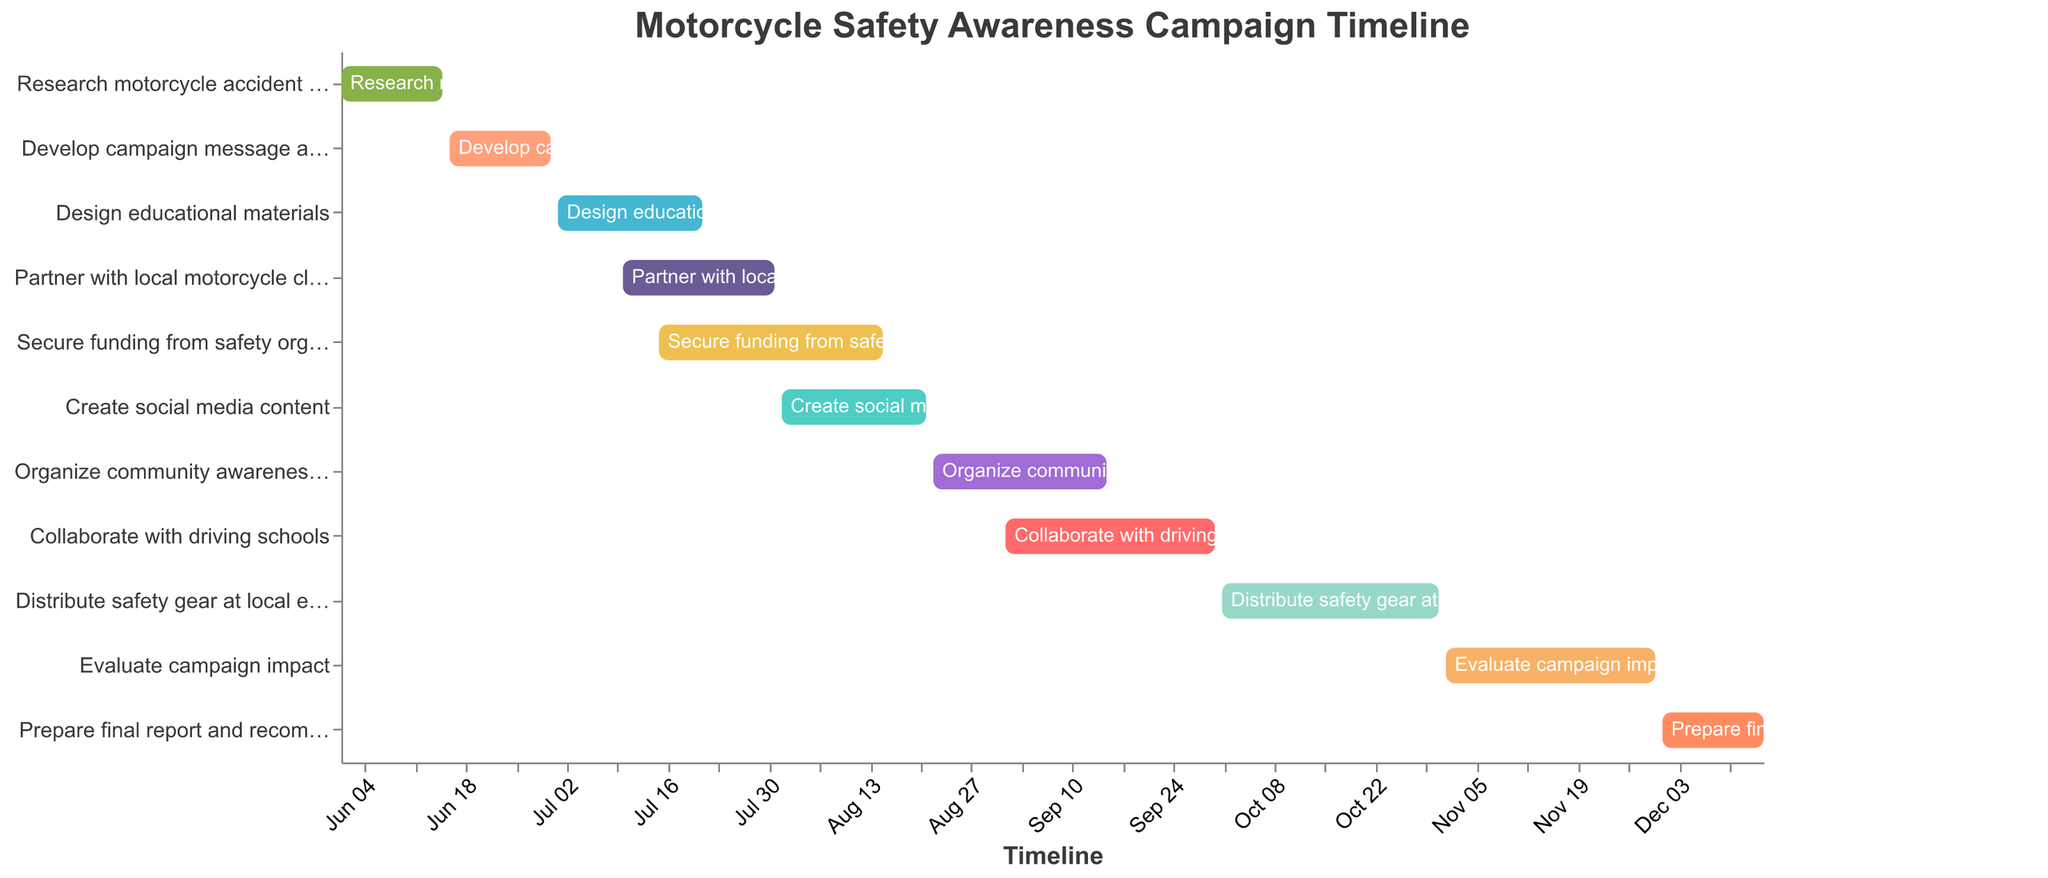How long was the “Research motorcycle accident statistics” phase? Check the dates for "Research motorcycle accident statistics," which spans from June 1, 2023, to June 15, 2023. Count the days between these two dates.
Answer: 15 days What is the title of the figure? Refer to the top section of the figure where the title is usually displayed.
Answer: Motorcycle Safety Awareness Campaign Timeline When does the "Design educational materials" task end? Locate the task "Design educational materials" and check the end date listed for this task.
Answer: July 21, 2023 Which task starts at the earliest date? Look for the task with the earliest start date in the list of tasks.
Answer: Research motorcycle accident statistics How many tasks are scheduled to end in September 2023? Identify tasks with end dates in September 2023. There are two tasks: "Organize community awareness events" (September 15, 2023) and "Collaborate with driving schools" (September 30, 2023). Count them.
Answer: 2 tasks Which task has the longest duration? Calculate the duration of each task by subtracting the start date from the end date. Identify the task with the longest duration.
Answer: Secure funding from safety organizations (July 15, 2023, to August 15, 2023) Which two tasks have overlapping timelines in July 2023? Look at the tasks scheduled in July 2023 and identify if any start and end dates overlap. "Design educational materials" (July 1, 2023, to July 21, 2023) and “Partner with local motorcycle clubs” (July 10, 2023, to July 31, 2023) overlap.
Answer: Design educational materials and Partner with local motorcycle clubs Which task follows immediately after "Develop campaign message and slogan"? Refer to the end date of "Develop campaign message and slogan" and see which task begins promptly after it.
Answer: Design educational materials What is the color coding used to represent different tasks? Notice the different colors assigned to various tasks in the Gantt chart. Each task has its unique color.
Answer: Unique colors for each task When do both “Create social media content” and “Organize community awareness events” overlap? Check the timeline for both tasks. "Create social media content" runs from August 1 to August 21, 2023, and "Organize community awareness events" from August 22 to September 15, 2023. They overlap in August.
Answer: August 22-21, 2023 